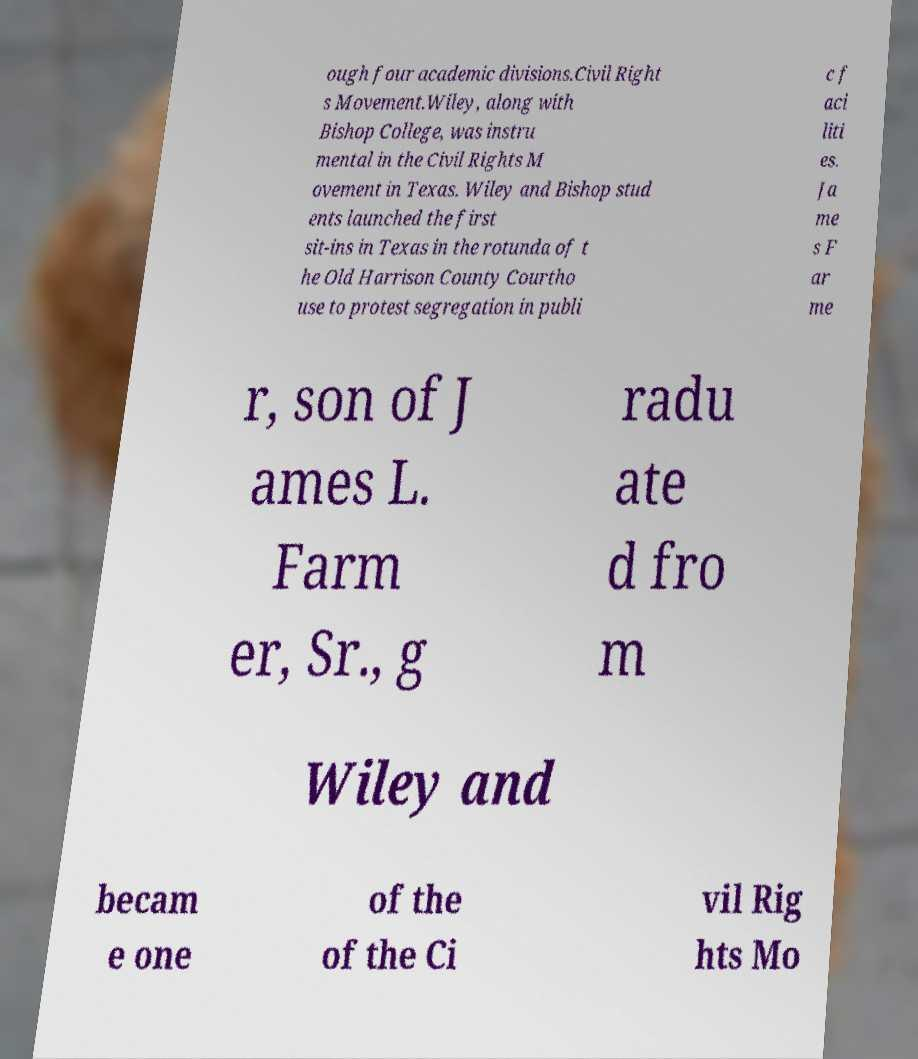Could you assist in decoding the text presented in this image and type it out clearly? ough four academic divisions.Civil Right s Movement.Wiley, along with Bishop College, was instru mental in the Civil Rights M ovement in Texas. Wiley and Bishop stud ents launched the first sit-ins in Texas in the rotunda of t he Old Harrison County Courtho use to protest segregation in publi c f aci liti es. Ja me s F ar me r, son of J ames L. Farm er, Sr., g radu ate d fro m Wiley and becam e one of the of the Ci vil Rig hts Mo 